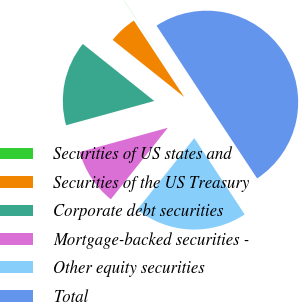Convert chart to OTSL. <chart><loc_0><loc_0><loc_500><loc_500><pie_chart><fcel>Securities of US states and<fcel>Securities of the US Treasury<fcel>Corporate debt securities<fcel>Mortgage-backed securities -<fcel>Other equity securities<fcel>Total<nl><fcel>0.02%<fcel>5.01%<fcel>15.0%<fcel>10.01%<fcel>20.0%<fcel>49.96%<nl></chart> 